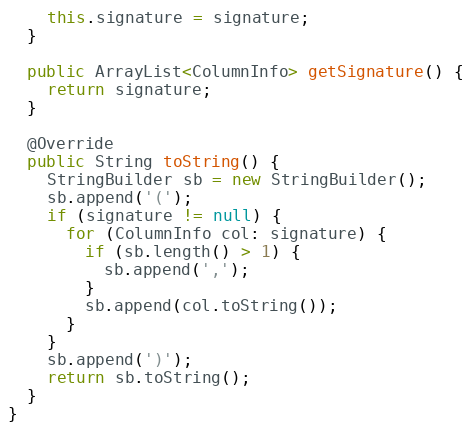Convert code to text. <code><loc_0><loc_0><loc_500><loc_500><_Java_>    this.signature = signature;
  }

  public ArrayList<ColumnInfo> getSignature() {
    return signature;
  }

  @Override
  public String toString() {
    StringBuilder sb = new StringBuilder();
    sb.append('(');
    if (signature != null) {
      for (ColumnInfo col: signature) {
        if (sb.length() > 1) {
          sb.append(',');
        }
        sb.append(col.toString());
      }
    }
    sb.append(')');
    return sb.toString();
  }
}
</code> 